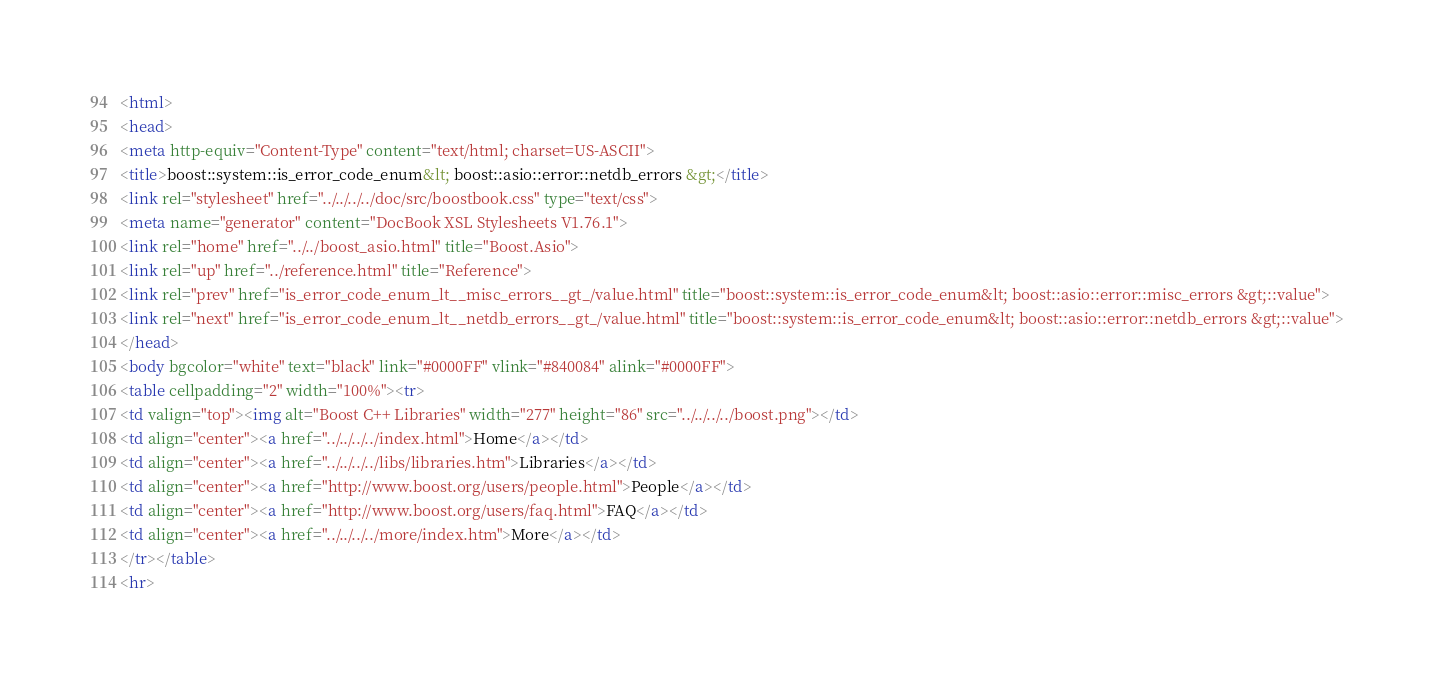Convert code to text. <code><loc_0><loc_0><loc_500><loc_500><_HTML_><html>
<head>
<meta http-equiv="Content-Type" content="text/html; charset=US-ASCII">
<title>boost::system::is_error_code_enum&lt; boost::asio::error::netdb_errors &gt;</title>
<link rel="stylesheet" href="../../../../doc/src/boostbook.css" type="text/css">
<meta name="generator" content="DocBook XSL Stylesheets V1.76.1">
<link rel="home" href="../../boost_asio.html" title="Boost.Asio">
<link rel="up" href="../reference.html" title="Reference">
<link rel="prev" href="is_error_code_enum_lt__misc_errors__gt_/value.html" title="boost::system::is_error_code_enum&lt; boost::asio::error::misc_errors &gt;::value">
<link rel="next" href="is_error_code_enum_lt__netdb_errors__gt_/value.html" title="boost::system::is_error_code_enum&lt; boost::asio::error::netdb_errors &gt;::value">
</head>
<body bgcolor="white" text="black" link="#0000FF" vlink="#840084" alink="#0000FF">
<table cellpadding="2" width="100%"><tr>
<td valign="top"><img alt="Boost C++ Libraries" width="277" height="86" src="../../../../boost.png"></td>
<td align="center"><a href="../../../../index.html">Home</a></td>
<td align="center"><a href="../../../../libs/libraries.htm">Libraries</a></td>
<td align="center"><a href="http://www.boost.org/users/people.html">People</a></td>
<td align="center"><a href="http://www.boost.org/users/faq.html">FAQ</a></td>
<td align="center"><a href="../../../../more/index.htm">More</a></td>
</tr></table>
<hr></code> 